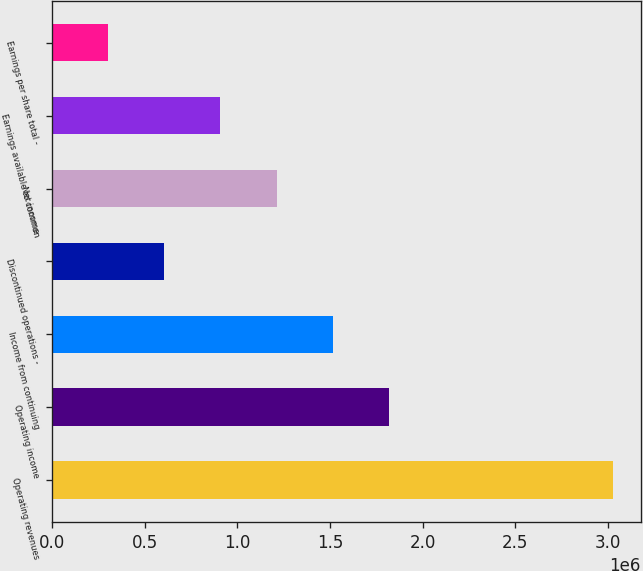Convert chart. <chart><loc_0><loc_0><loc_500><loc_500><bar_chart><fcel>Operating revenues<fcel>Operating income<fcel>Income from continuing<fcel>Discontinued operations -<fcel>Net income<fcel>Earnings available to common<fcel>Earnings per share total -<nl><fcel>3.02839e+06<fcel>1.81703e+06<fcel>1.51419e+06<fcel>605678<fcel>1.21136e+06<fcel>908517<fcel>302839<nl></chart> 